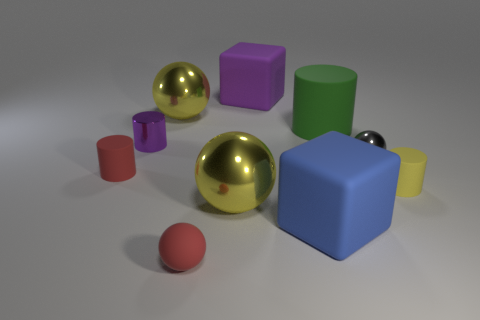If we were to categorize these objects by size, which would you place in the large, medium, and small categories? In terms of size, I would categorize the blue and green cubes as large objects; the red rubber cylinder, yellow cylinders, violet cube, and gold sphere as medium objects; and the small red and silver spheres as small objects. 